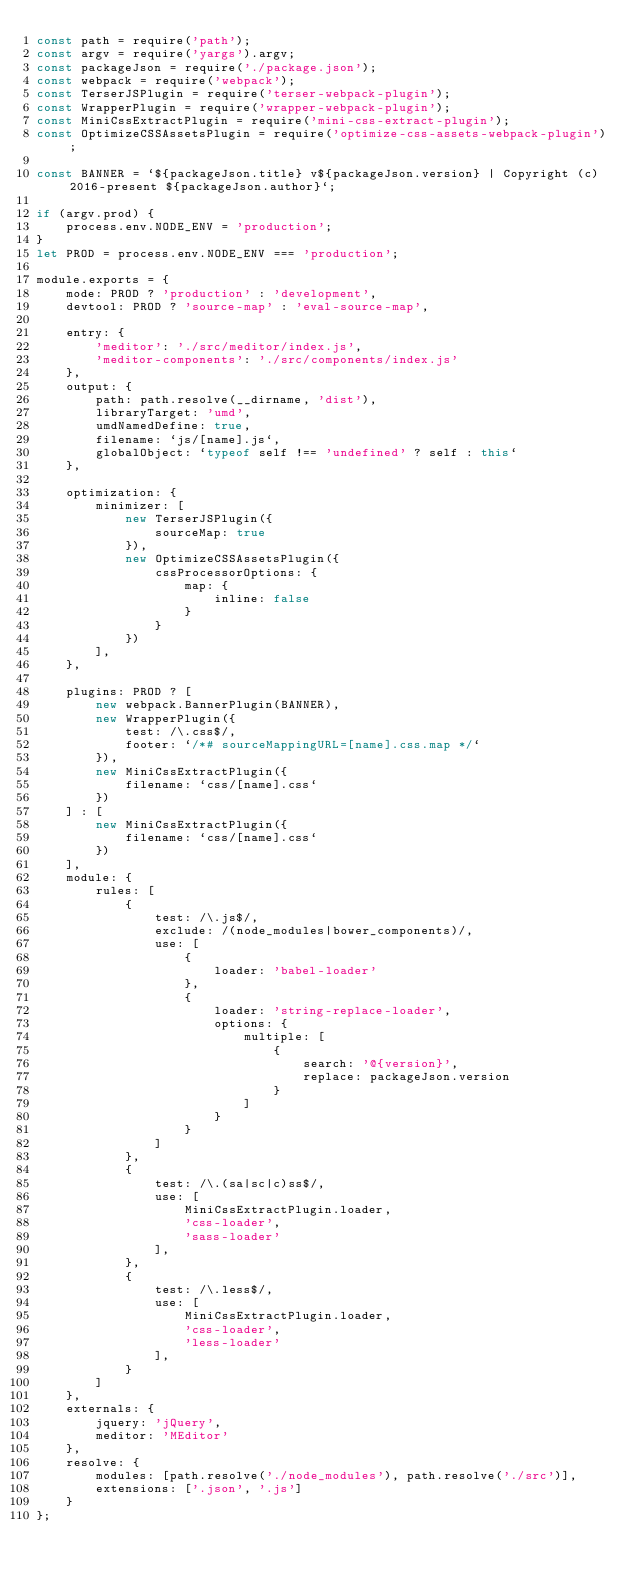<code> <loc_0><loc_0><loc_500><loc_500><_JavaScript_>const path = require('path');
const argv = require('yargs').argv;
const packageJson = require('./package.json');
const webpack = require('webpack');
const TerserJSPlugin = require('terser-webpack-plugin');
const WrapperPlugin = require('wrapper-webpack-plugin');
const MiniCssExtractPlugin = require('mini-css-extract-plugin');
const OptimizeCSSAssetsPlugin = require('optimize-css-assets-webpack-plugin');

const BANNER = `${packageJson.title} v${packageJson.version} | Copyright (c) 2016-present ${packageJson.author}`;

if (argv.prod) {
    process.env.NODE_ENV = 'production';
}
let PROD = process.env.NODE_ENV === 'production';

module.exports = {
    mode: PROD ? 'production' : 'development',
    devtool: PROD ? 'source-map' : 'eval-source-map',
    
    entry: {
        'meditor': './src/meditor/index.js',
        'meditor-components': './src/components/index.js'
    },
    output: {
        path: path.resolve(__dirname, 'dist'),
        libraryTarget: 'umd',
        umdNamedDefine: true,
        filename: `js/[name].js`,
        globalObject: `typeof self !== 'undefined' ? self : this`
    },
    
    optimization: {
        minimizer: [
            new TerserJSPlugin({
                sourceMap: true
            }),
            new OptimizeCSSAssetsPlugin({
                cssProcessorOptions: {
                    map: {
                        inline: false
                    }
                }
            })
        ],
    },
    
    plugins: PROD ? [
        new webpack.BannerPlugin(BANNER),
        new WrapperPlugin({
            test: /\.css$/,
            footer: `/*# sourceMappingURL=[name].css.map */`
        }),
        new MiniCssExtractPlugin({
            filename: `css/[name].css`
        })
    ] : [
        new MiniCssExtractPlugin({
            filename: `css/[name].css`
        })
    ],
    module: {
        rules: [
            {
                test: /\.js$/,
                exclude: /(node_modules|bower_components)/,
                use: [
                    {
                        loader: 'babel-loader'
                    },
                    {
                        loader: 'string-replace-loader',
                        options: {
                            multiple: [
                                {
                                    search: '@{version}',
                                    replace: packageJson.version
                                }
                            ]
                        }
                    }
                ]
            },
            {
                test: /\.(sa|sc|c)ss$/,
                use: [
                    MiniCssExtractPlugin.loader,
                    'css-loader',
                    'sass-loader'
                ],
            },
            {
                test: /\.less$/,
                use: [
                    MiniCssExtractPlugin.loader,
                    'css-loader',
                    'less-loader'
                ],
            }
        ]
    },
    externals: {
        jquery: 'jQuery',
        meditor: 'MEditor'
    },
    resolve: {
        modules: [path.resolve('./node_modules'), path.resolve('./src')],
        extensions: ['.json', '.js']
    }
};
</code> 